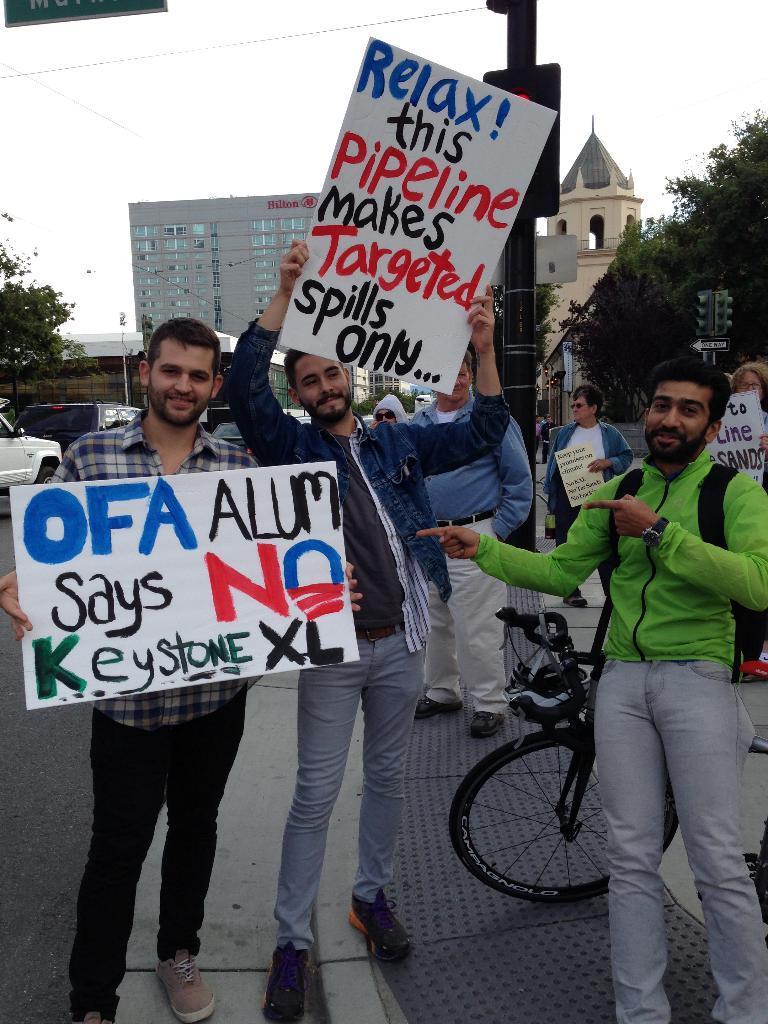How would you summarize this image in a sentence or two? In this picture we can see two boys standing in the front, holding protesting boards in the hand, smiling and giving a pose to the camera. Behind there is a signal pole, trees and glass building. 